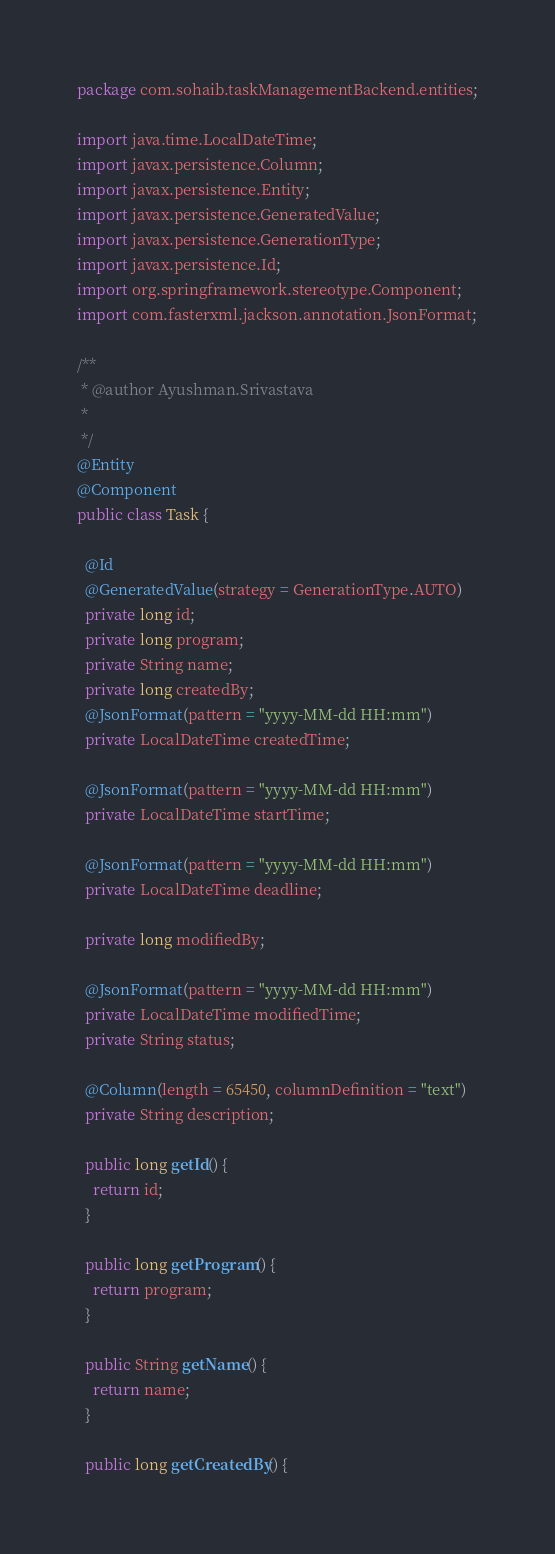<code> <loc_0><loc_0><loc_500><loc_500><_Java_>package com.sohaib.taskManagementBackend.entities;

import java.time.LocalDateTime;
import javax.persistence.Column;
import javax.persistence.Entity;
import javax.persistence.GeneratedValue;
import javax.persistence.GenerationType;
import javax.persistence.Id;
import org.springframework.stereotype.Component;
import com.fasterxml.jackson.annotation.JsonFormat;

/**
 * @author Ayushman.Srivastava
 *
 */
@Entity
@Component
public class Task {

  @Id
  @GeneratedValue(strategy = GenerationType.AUTO)
  private long id;
  private long program;
  private String name;
  private long createdBy;
  @JsonFormat(pattern = "yyyy-MM-dd HH:mm")
  private LocalDateTime createdTime;
  
  @JsonFormat(pattern = "yyyy-MM-dd HH:mm")
  private LocalDateTime startTime;
  
  @JsonFormat(pattern = "yyyy-MM-dd HH:mm")
  private LocalDateTime deadline;
  
  private long modifiedBy;

  @JsonFormat(pattern = "yyyy-MM-dd HH:mm")
  private LocalDateTime modifiedTime;
  private String status;
  
  @Column(length = 65450, columnDefinition = "text")
  private String description;
  
  public long getId() {
    return id;
  }

  public long getProgram() {
    return program;
  }

  public String getName() {
    return name;
  }

  public long getCreatedBy() {</code> 